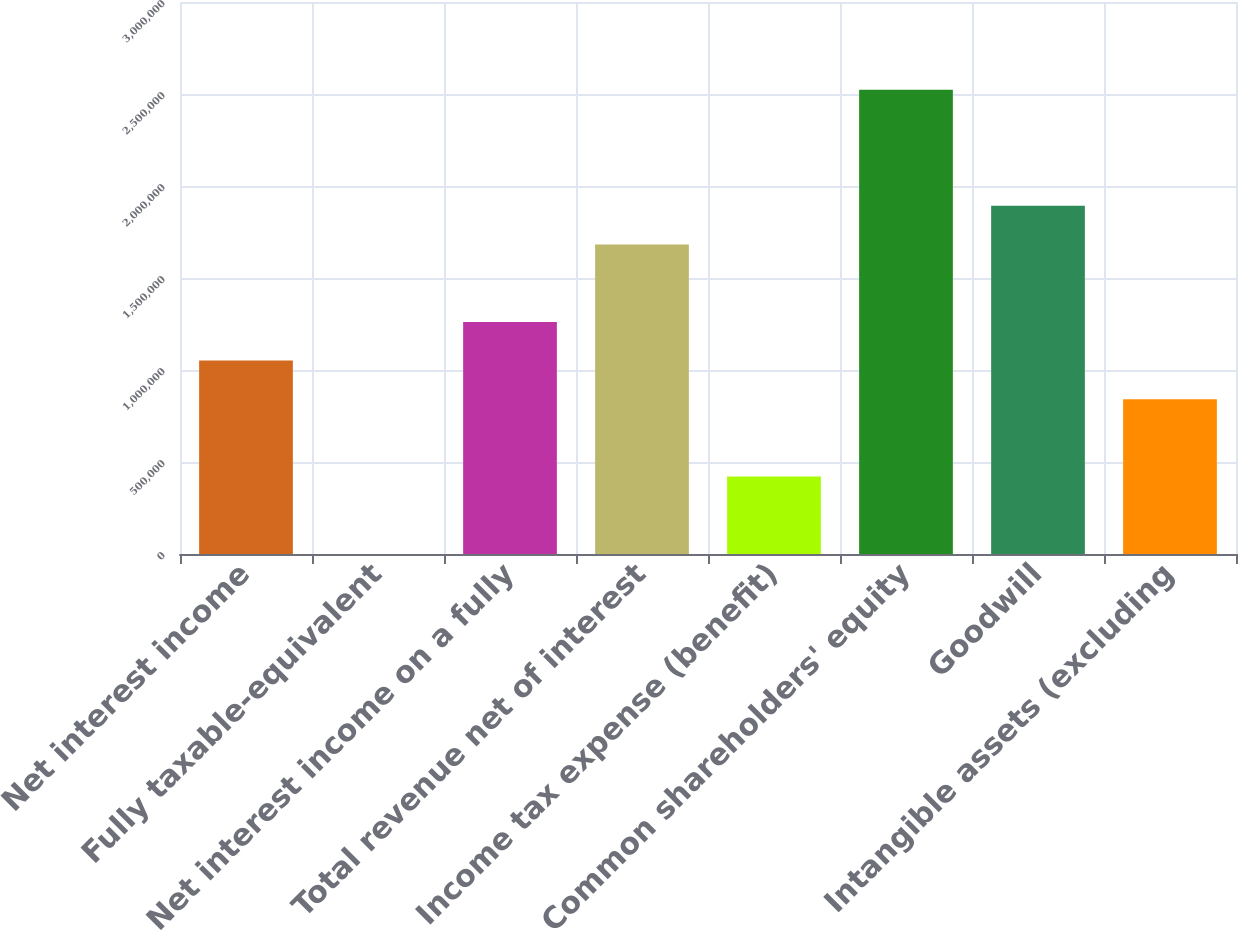<chart> <loc_0><loc_0><loc_500><loc_500><bar_chart><fcel>Net interest income<fcel>Fully taxable-equivalent<fcel>Net interest income on a fully<fcel>Total revenue net of interest<fcel>Income tax expense (benefit)<fcel>Common shareholders' equity<fcel>Goodwill<fcel>Intangible assets (excluding<nl><fcel>1.05124e+06<fcel>213<fcel>1.26145e+06<fcel>1.68186e+06<fcel>420625<fcel>2.52268e+06<fcel>1.89207e+06<fcel>841037<nl></chart> 